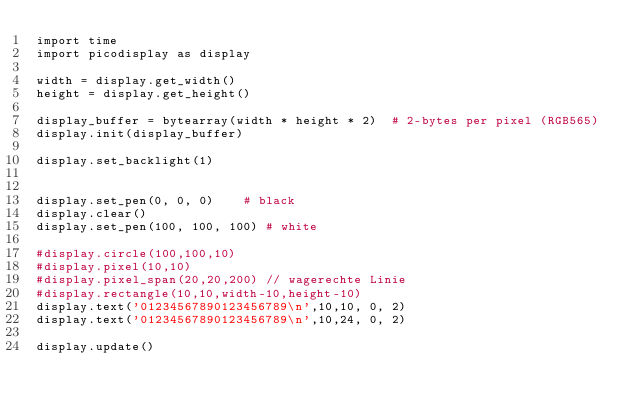<code> <loc_0><loc_0><loc_500><loc_500><_Python_>import time
import picodisplay as display 

width = display.get_width()
height = display.get_height()

display_buffer = bytearray(width * height * 2)  # 2-bytes per pixel (RGB565)
display.init(display_buffer)

display.set_backlight(1)


display.set_pen(0, 0, 0)    # black
display.clear()
display.set_pen(100, 100, 100) # white

#display.circle(100,100,10)
#display.pixel(10,10)
#display.pixel_span(20,20,200) // wagerechte Linie
#display.rectangle(10,10,width-10,height-10)
display.text('01234567890123456789\n',10,10, 0, 2)
display.text('01234567890123456789\n',10,24, 0, 2)
        
display.update()
</code> 